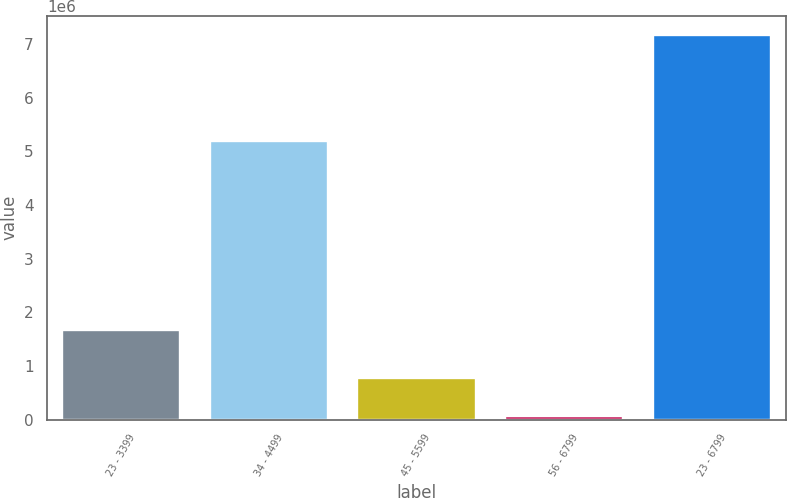<chart> <loc_0><loc_0><loc_500><loc_500><bar_chart><fcel>23 - 3399<fcel>34 - 4499<fcel>45 - 5599<fcel>56 - 6799<fcel>23 - 6799<nl><fcel>1.67443e+06<fcel>5.19549e+06<fcel>779813<fcel>70583<fcel>7.16288e+06<nl></chart> 